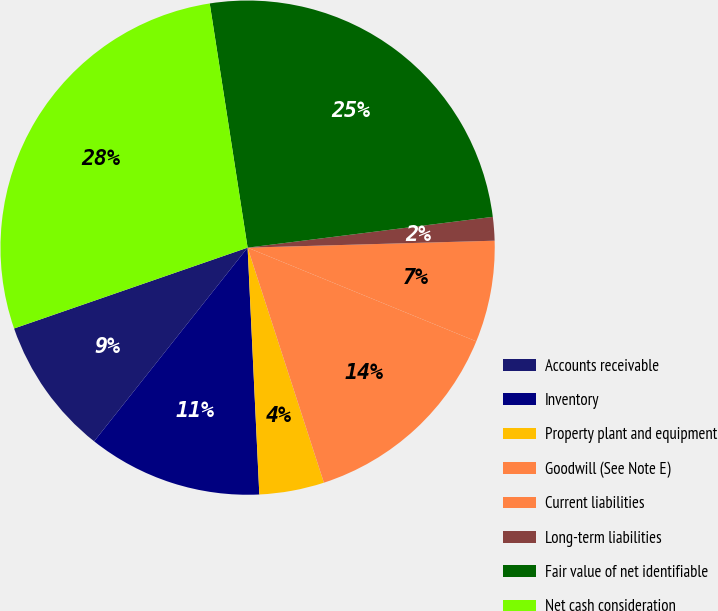Convert chart. <chart><loc_0><loc_0><loc_500><loc_500><pie_chart><fcel>Accounts receivable<fcel>Inventory<fcel>Property plant and equipment<fcel>Goodwill (See Note E)<fcel>Current liabilities<fcel>Long-term liabilities<fcel>Fair value of net identifiable<fcel>Net cash consideration<nl><fcel>9.03%<fcel>11.42%<fcel>4.24%<fcel>13.81%<fcel>6.64%<fcel>1.54%<fcel>25.46%<fcel>27.85%<nl></chart> 